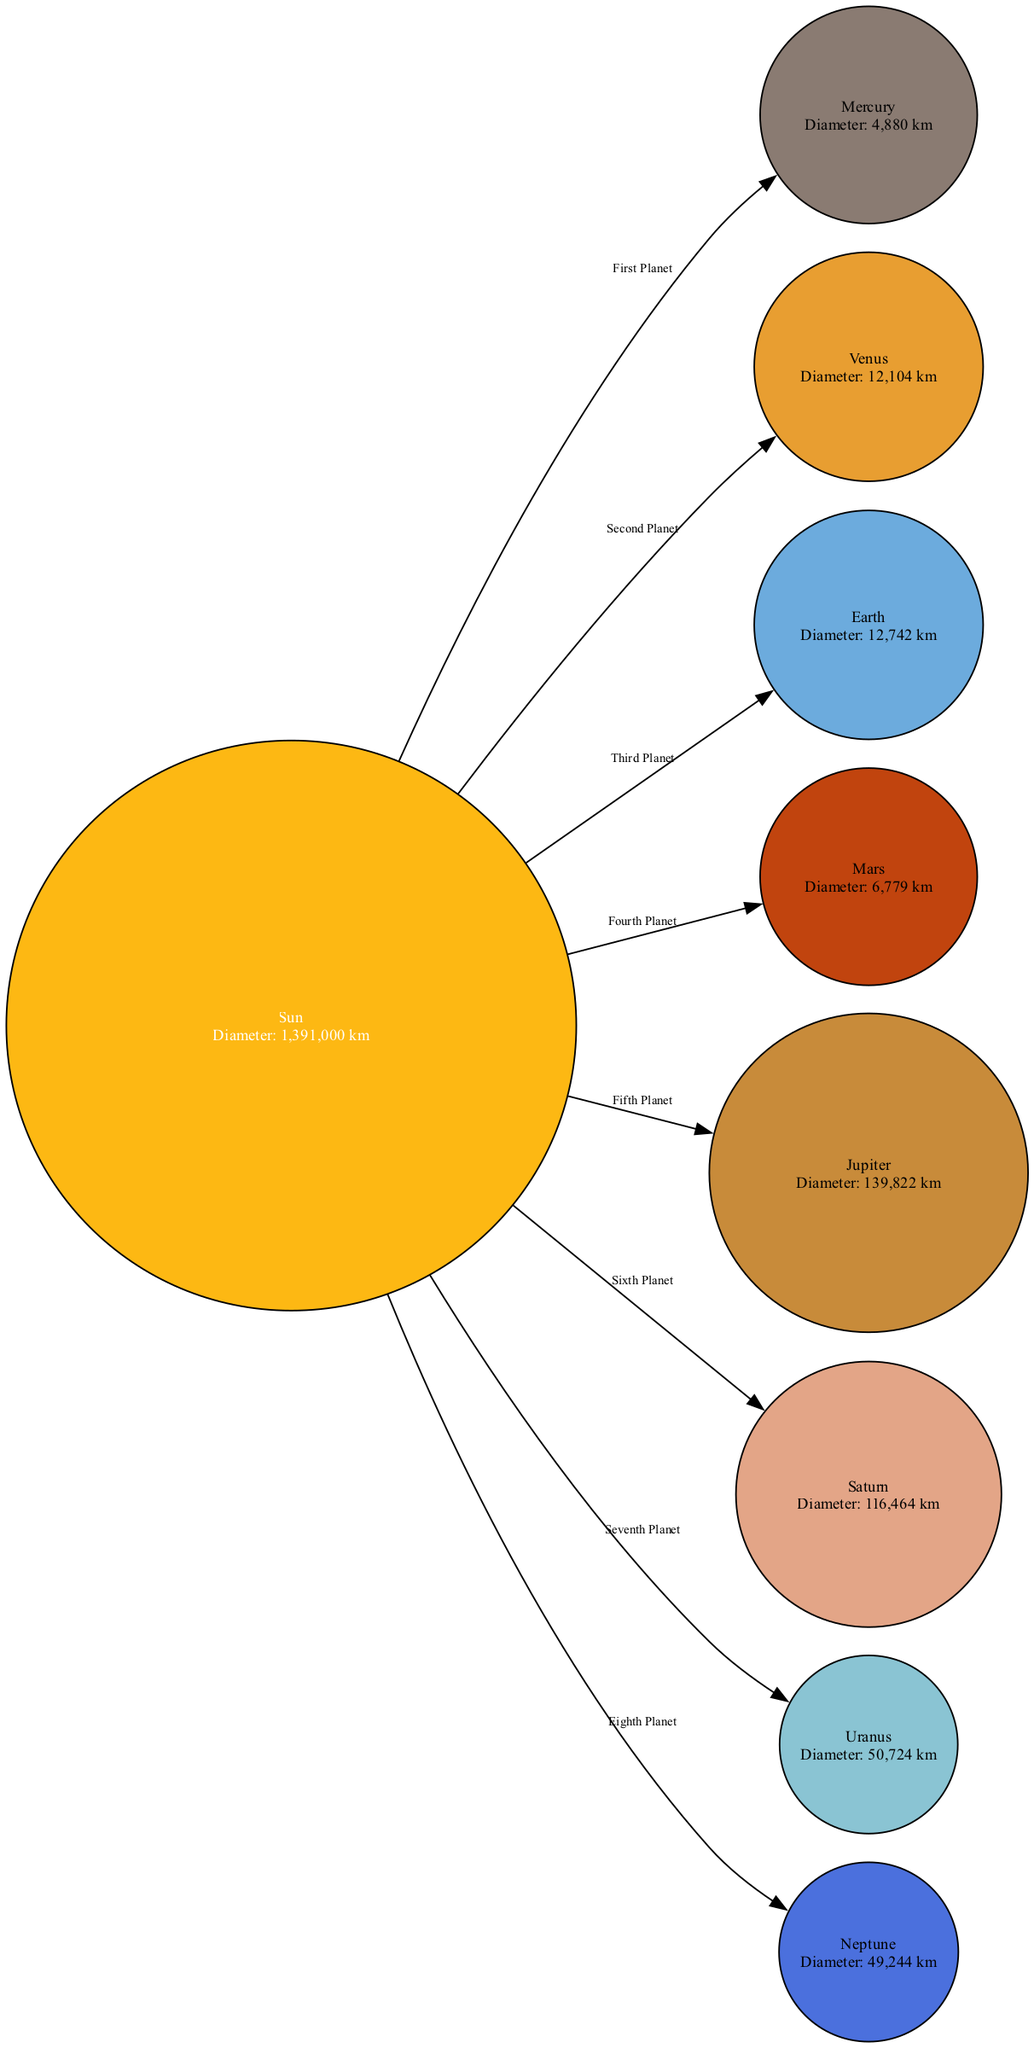What is the diameter of Jupiter? The diagram shows Jupiter with the label "Diameter: 139,822 km" directly associated with it. Therefore, we take this value as the answer.
Answer: 139,822 km How many planets are depicted in the diagram? By counting the nodes shown in the diagram, we find that there are 8 planets (including the Sun as the central body).
Answer: 8 Which planet is closest to the Sun? The diagram indicates that Mercury is the first planet connected to the Sun, signifying its proximity as the closest planet.
Answer: Mercury What is the diameter of Mars? The label linked with Mars states, "Diameter: 6,779 km," which can be drawn directly from the information in the diagram.
Answer: 6,779 km Which planet has the smallest diameter? Upon comparing the diameters listed, Mercury has the smallest diameter, as it is labeled "Diameter: 4,880 km," which is less than that of any other planet.
Answer: Mercury What is the diameter of Neptune? The information for Neptune provided in the diagram states, "Diameter: 49,244 km." This figure is clearly displayed alongside Neptune's label.
Answer: 49,244 km Which planet is labeled as the seventh planet from the Sun? The diagram specifies Uranus as the seventh planet from the Sun, as indicated by its position and the label connected to it.
Answer: Uranus Which planet has a diameter greater than 100,000 km? From the diameter values provided, only Jupiter exceeds 100,000 km, as it is labeled "Diameter: 139,822 km." Thus, the answer is clear from the provided data.
Answer: Jupiter What planet is labeled as the second planet? Looking at the diagram, Venus is connected to the Sun and is labeled as the second planet in the order, confirmed by the edge label "Second Planet."
Answer: Venus 